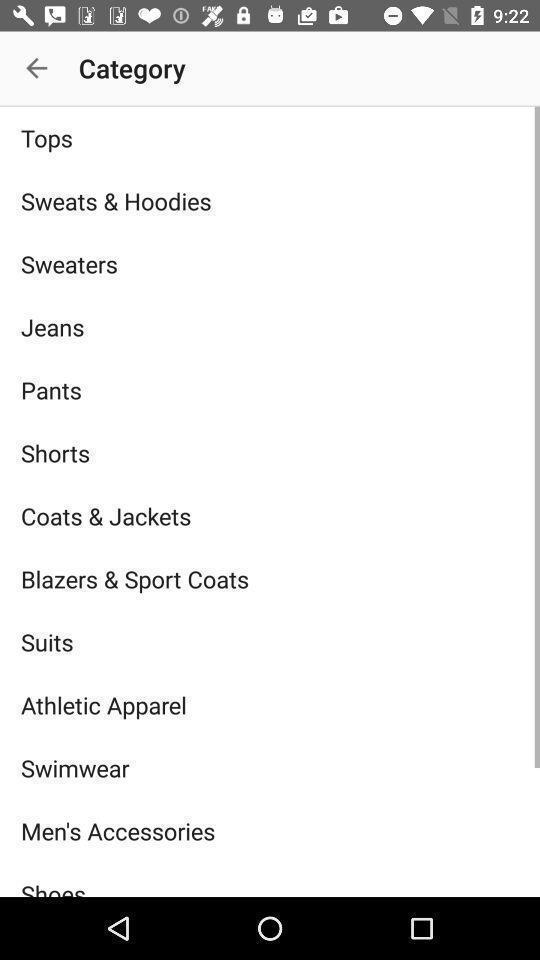Provide a detailed account of this screenshot. Screen shows different categories of clothing. 